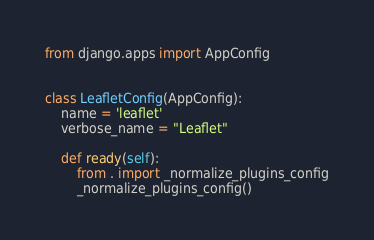Convert code to text. <code><loc_0><loc_0><loc_500><loc_500><_Python_>
from django.apps import AppConfig


class LeafletConfig(AppConfig):
    name = 'leaflet'
    verbose_name = "Leaflet"

    def ready(self):
        from . import _normalize_plugins_config
        _normalize_plugins_config()
</code> 